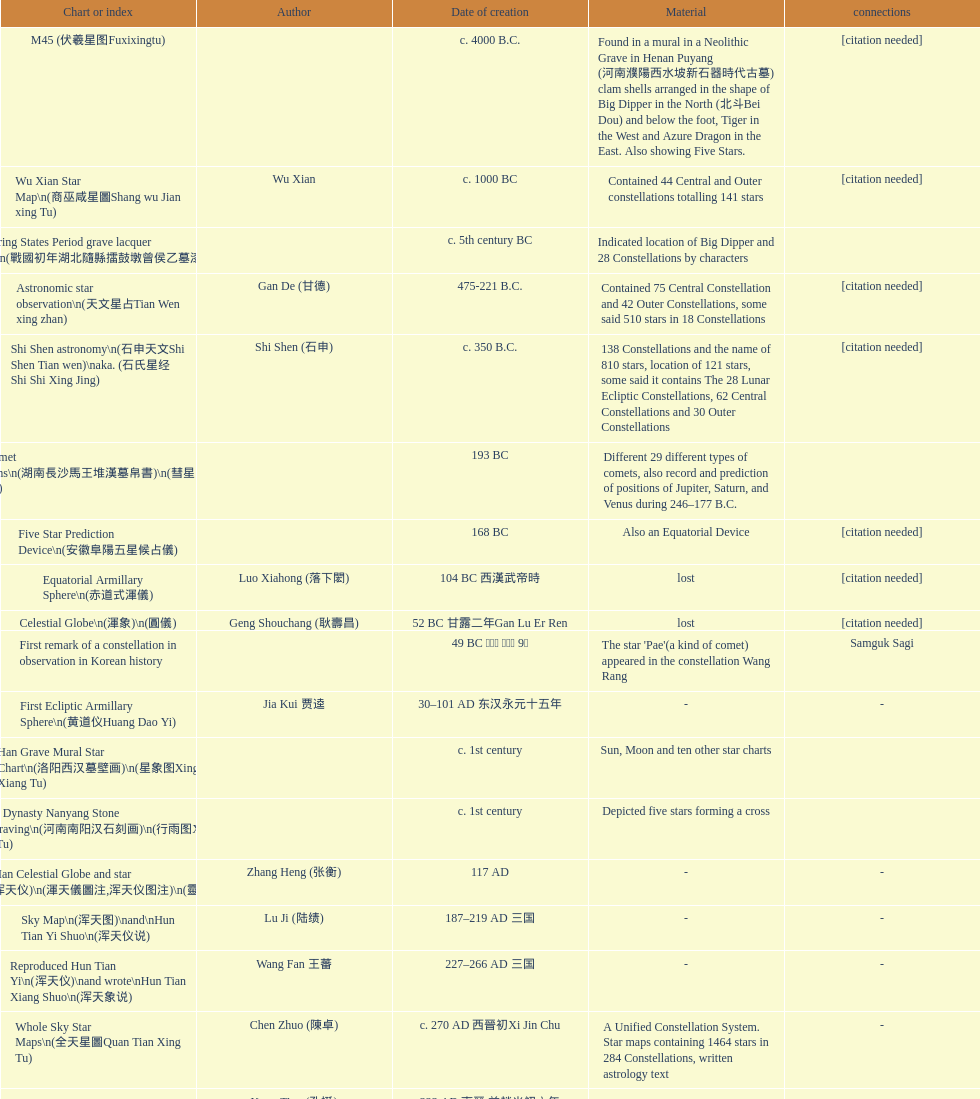What is the name of the oldest map/catalog? M45. 